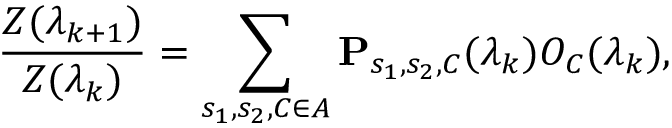Convert formula to latex. <formula><loc_0><loc_0><loc_500><loc_500>\frac { Z ( \lambda _ { k + 1 } ) } { Z ( \lambda _ { k } ) } = \sum _ { s _ { 1 } , s _ { 2 } , C \in A } P _ { s _ { 1 } , s _ { 2 } , C } ( \lambda _ { k } ) O _ { C } ( \lambda _ { k } ) ,</formula> 